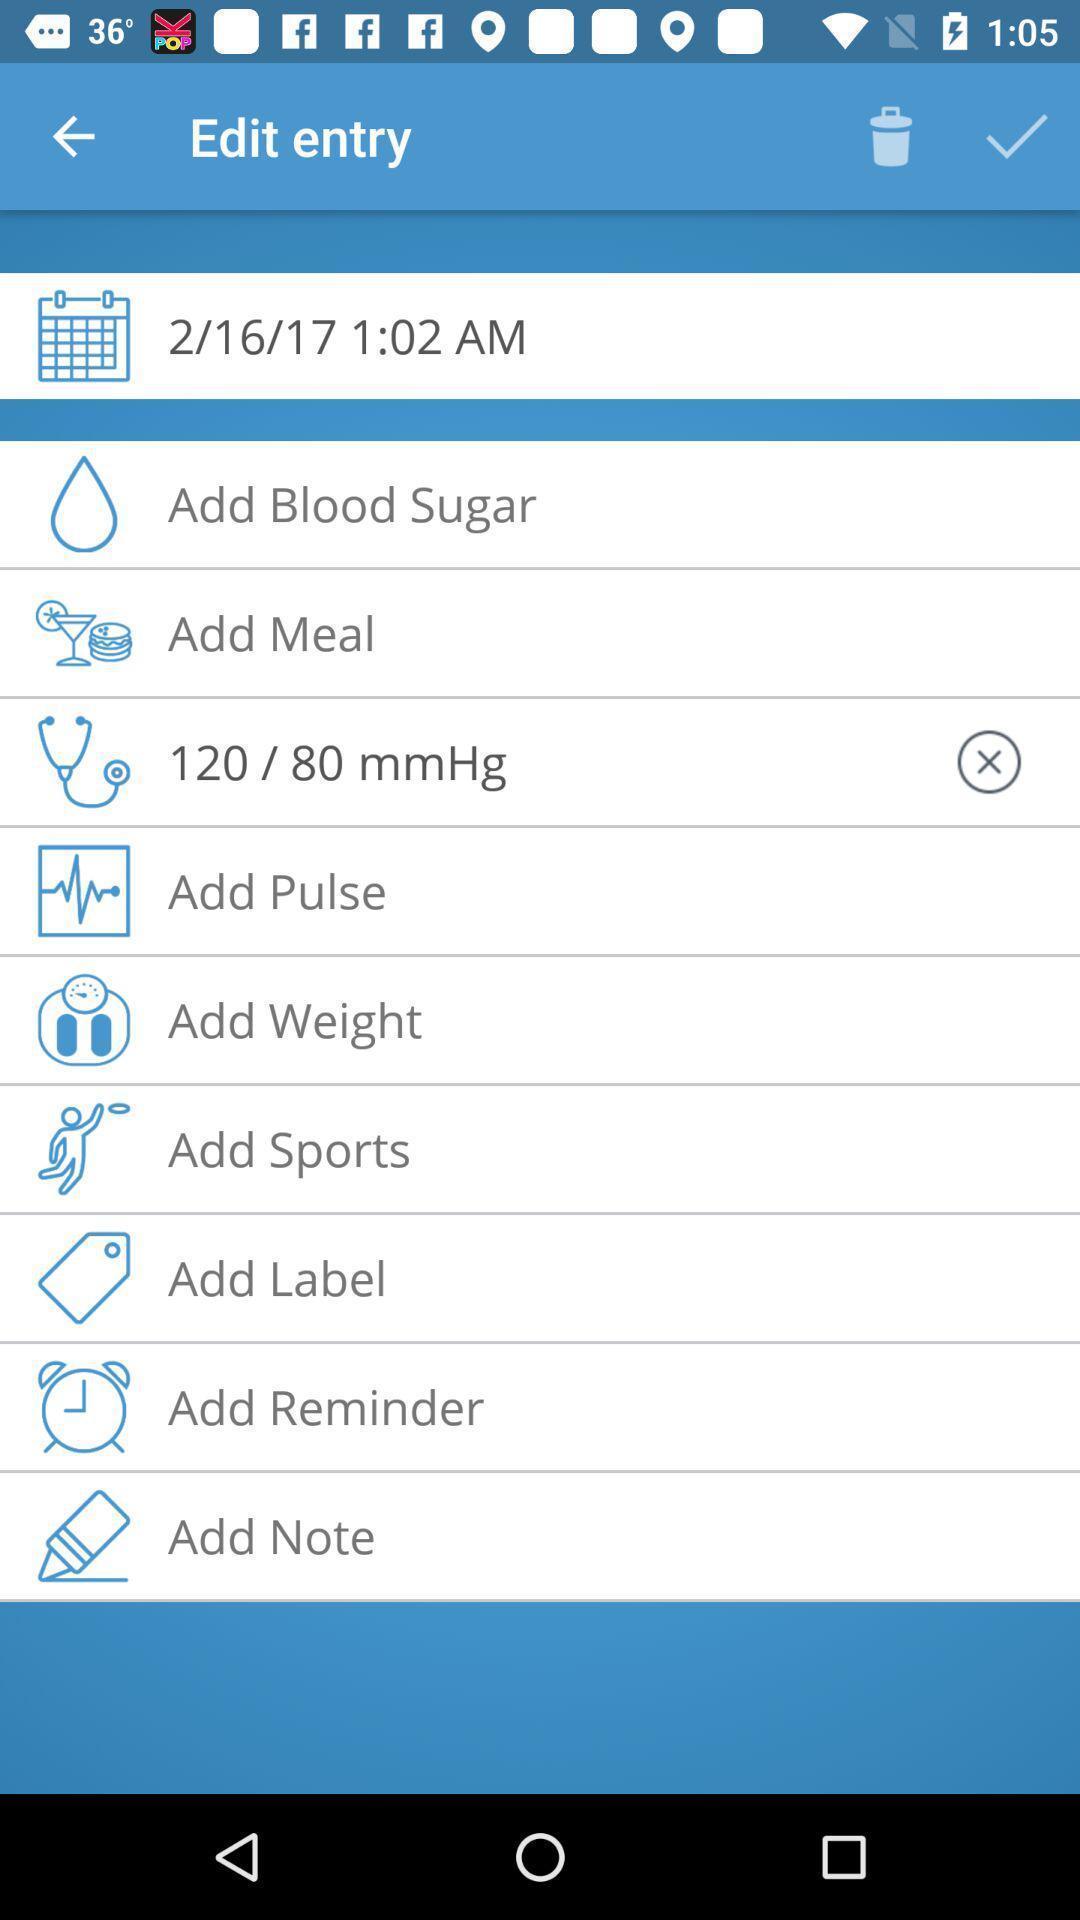Explain the elements present in this screenshot. Screen showing edit entry in an medical application. 